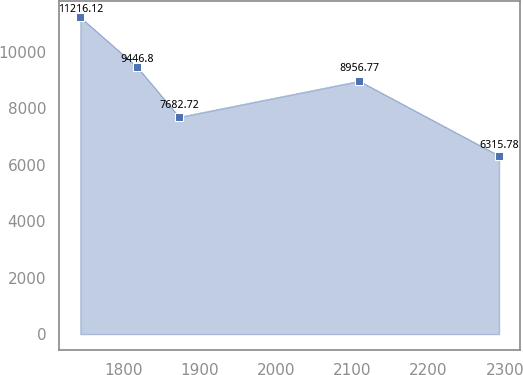Convert chart to OTSL. <chart><loc_0><loc_0><loc_500><loc_500><line_chart><ecel><fcel>Unnamed: 1<nl><fcel>1743.6<fcel>11216.1<nl><fcel>1818.39<fcel>9446.8<nl><fcel>1873.26<fcel>7682.72<nl><fcel>2109.18<fcel>8956.77<nl><fcel>2292.34<fcel>6315.78<nl></chart> 